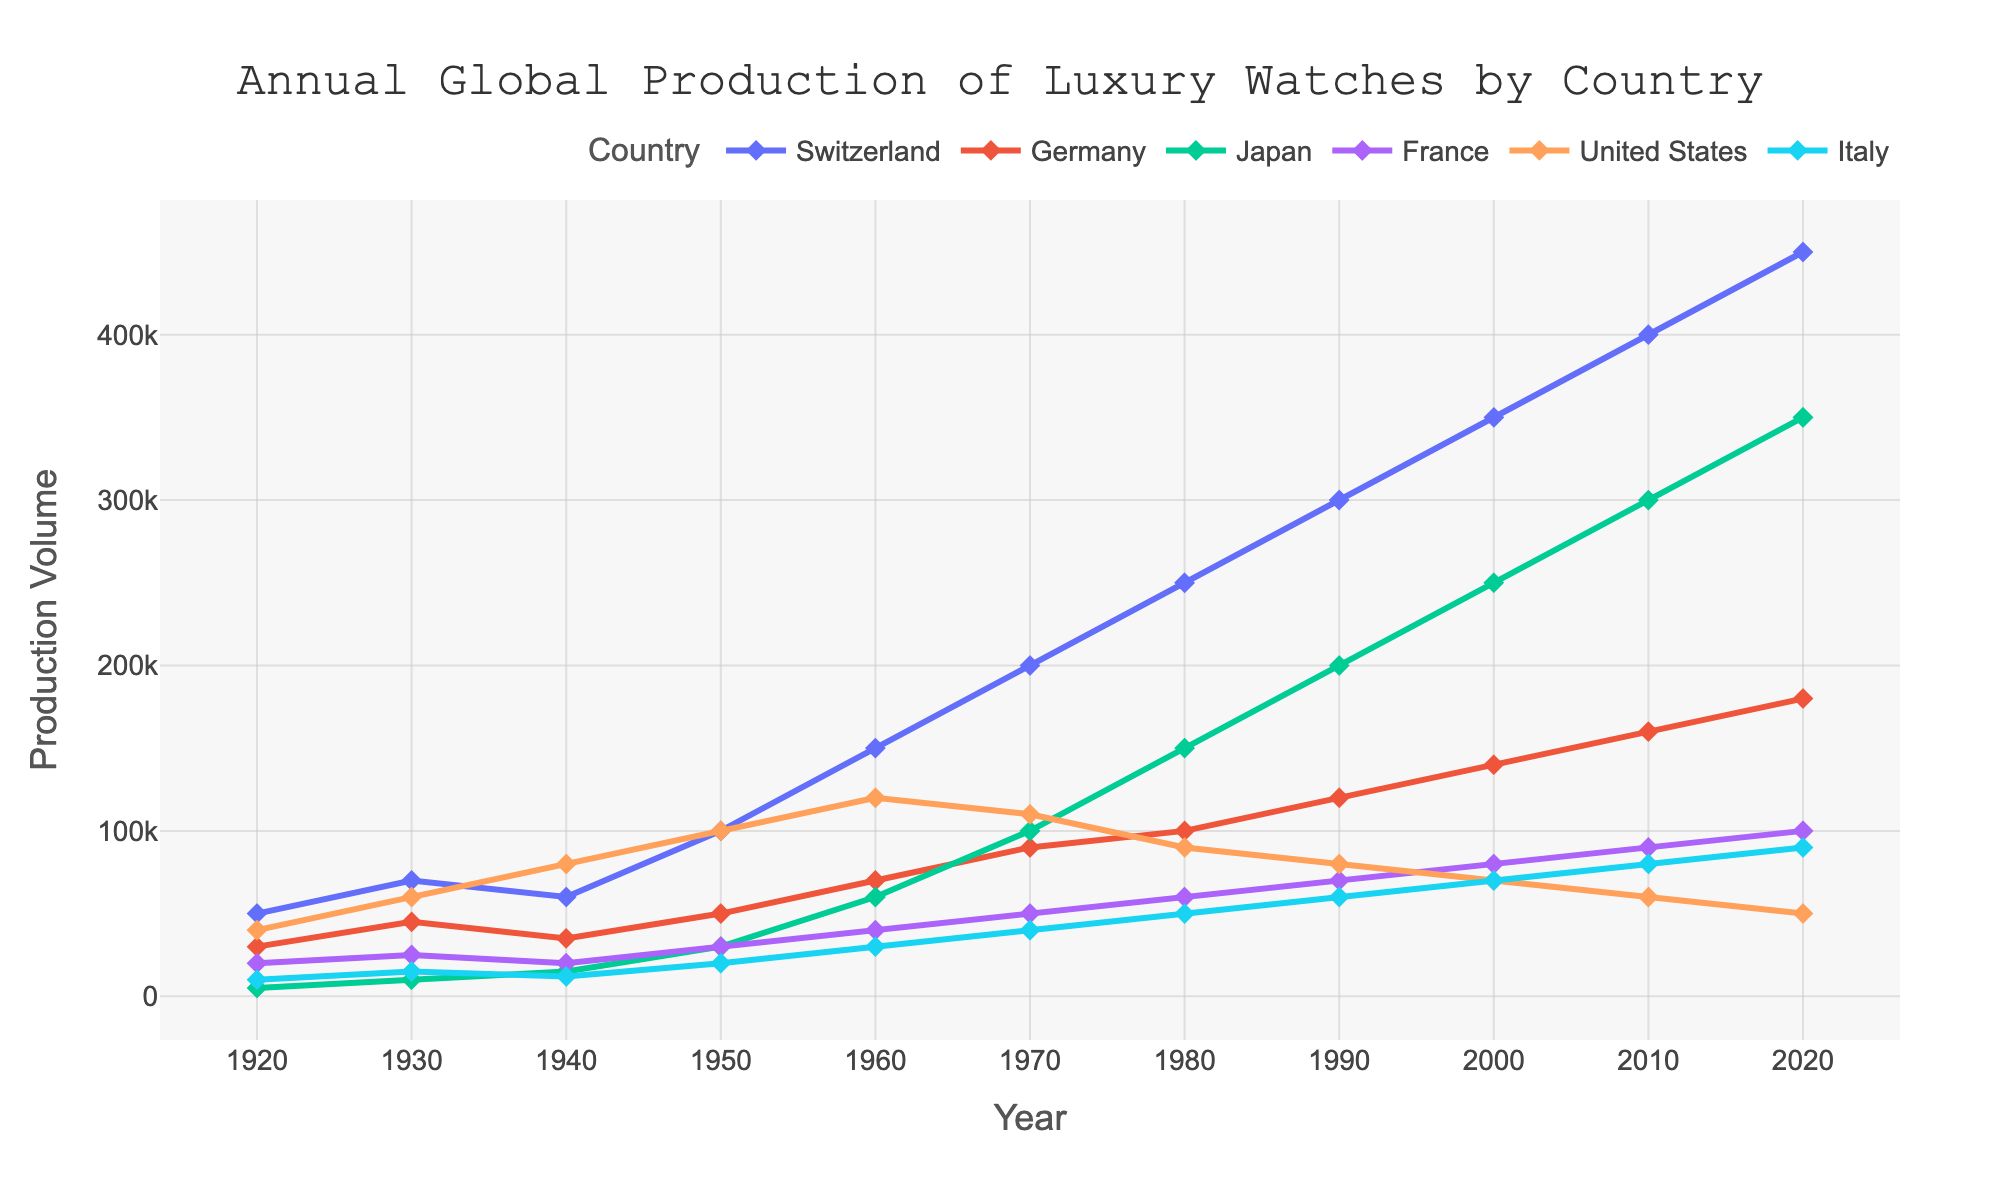What's the highest production volume reached by Japan? To find the highest production volume reached by Japan, check the data points for Japan across all years. The highest value is 350,000 in 2020.
Answer: 350,000 Which country had the most significant increase in production volume from 1940 to 1950? Look at the production volume change for each country between 1940 and 1950 by subtracting the 1940 value from the 1950 value. Switzerland had an increase from 60,000 to 100,000, so the increase is 40,000. Germany had an increase from 35,000 to 50,000 (15,000). Japan had an increase from 15,000 to 30,000 (15,000). France had an increase from 20,000 to 30,000 (10,000). The United States had an increase from 80,000 to 100,000 (20,000). Italy had an increase from 12,000 to 20,000 (8,000). Switzerland had the most significant increase of 40,000.
Answer: Switzerland Which country saw the steepest decline in production volume during any decade? Identify and compare the differences in production volume for each country between consecutive decades. The United States saw the steepest decline from 1960 to 1970, dropping from 120,000 to 110,000 (a decrease of 10,000).
Answer: United States What was the combined production volume of Germany and Italy in 1930? Add the production volumes of Germany and Italy in 1930. Germany had 45,000 and Italy had 15,000. The sum is 45,000 + 15,000 equals 60,000.
Answer: 60,000 Which country consistently increased its production volume every decade? Look at each country's production volume decade by decade to identify any consistent increases. Switzerland consistently increased from 1920 through 2020.
Answer: Switzerland How did the production volume of France in 2010 compare to its volume in 2000? Compare the production volumes of France in 2010 (90,000) and 2000 (80,000). The difference is 90,000 - 80,000 equals 10,000.
Answer: 10,000 more Which country had the lowest production volume in 1960? Observe the production volumes for all countries in 1960. Italy had the lowest production volume at 30,000.
Answer: Italy What is the trend in production volume for the United States from 1970 to 2020? Trace the production volumes for the United States from 1970 (110,000) to 2020 (50,000). The volumes continually decrease over this period.
Answer: Decreasing What's the average production volume for Switzerland over the entire period given? Sum the production volumes for Switzerland across all years and divide by the number of data points. The sum is 50000 + 70000 + 60000 + 100000 + 150000 + 200000 + 250000 + 300000 + 350000 + 400000 + 450000 which equals 2430000. There are 11 data points. The average is 2430000 / 11 equals approximately 220,909.
Answer: Approximately 220,909 Compare the production volume of Japan and Germany in 1990. Which one was higher and by how much? Look at the production volumes of Japan (200,000) and Germany (120,000) in 1990. Japan's production volume is higher. The difference is 200,000 - 120,000 equals 80,000.
Answer: Japan by 80,000 